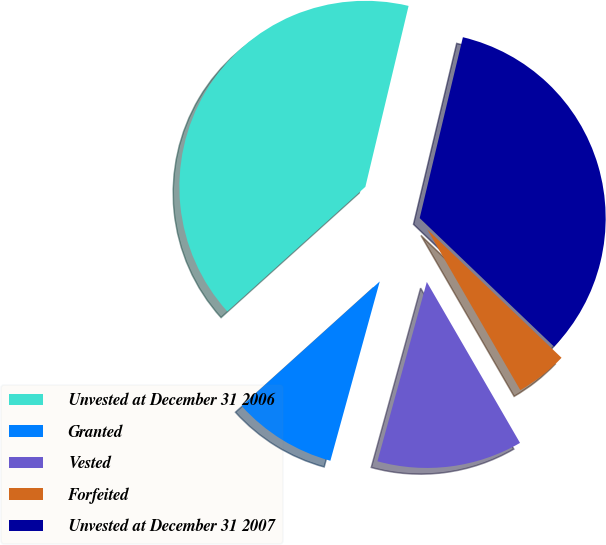Convert chart to OTSL. <chart><loc_0><loc_0><loc_500><loc_500><pie_chart><fcel>Unvested at December 31 2006<fcel>Granted<fcel>Vested<fcel>Forfeited<fcel>Unvested at December 31 2007<nl><fcel>40.41%<fcel>9.04%<fcel>12.63%<fcel>4.5%<fcel>33.41%<nl></chart> 